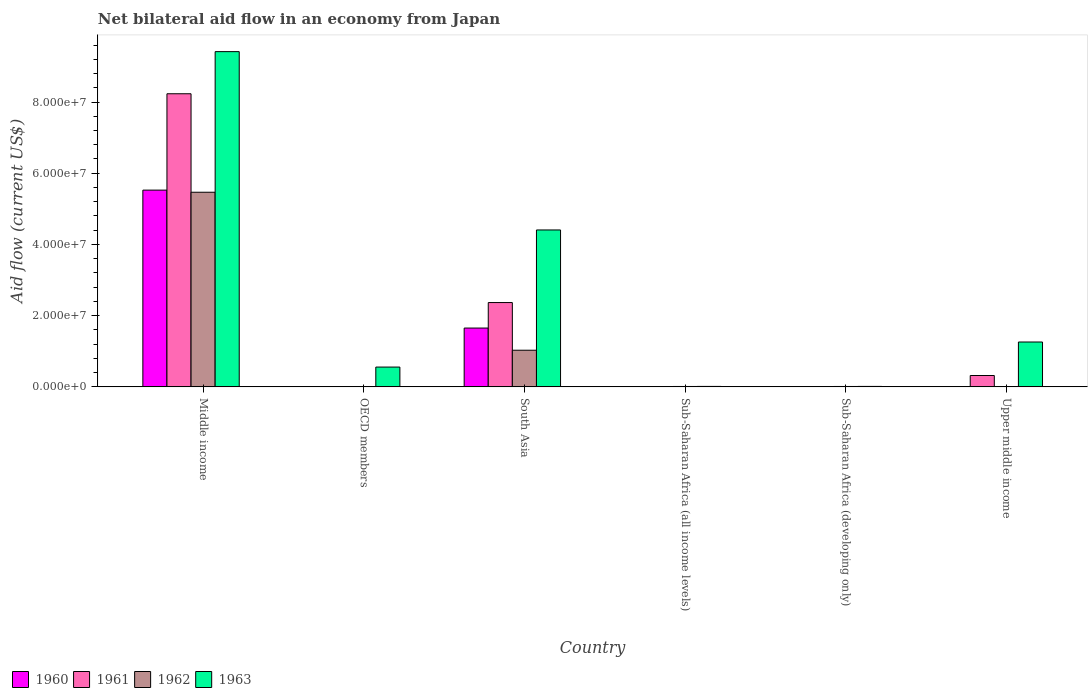How many groups of bars are there?
Keep it short and to the point. 6. Are the number of bars per tick equal to the number of legend labels?
Provide a succinct answer. No. How many bars are there on the 4th tick from the left?
Offer a very short reply. 4. What is the label of the 2nd group of bars from the left?
Keep it short and to the point. OECD members. In how many cases, is the number of bars for a given country not equal to the number of legend labels?
Offer a terse response. 1. Across all countries, what is the maximum net bilateral aid flow in 1962?
Your answer should be very brief. 5.47e+07. What is the total net bilateral aid flow in 1961 in the graph?
Make the answer very short. 1.09e+08. What is the difference between the net bilateral aid flow in 1960 in OECD members and that in Sub-Saharan Africa (developing only)?
Your answer should be compact. 10000. What is the difference between the net bilateral aid flow in 1962 in OECD members and the net bilateral aid flow in 1963 in Upper middle income?
Ensure brevity in your answer.  -1.25e+07. What is the average net bilateral aid flow in 1963 per country?
Your response must be concise. 2.61e+07. What is the difference between the net bilateral aid flow of/in 1963 and net bilateral aid flow of/in 1962 in Middle income?
Provide a short and direct response. 3.95e+07. In how many countries, is the net bilateral aid flow in 1960 greater than 64000000 US$?
Provide a succinct answer. 0. What is the ratio of the net bilateral aid flow in 1961 in OECD members to that in Sub-Saharan Africa (developing only)?
Provide a short and direct response. 1.67. Is the net bilateral aid flow in 1963 in OECD members less than that in Sub-Saharan Africa (developing only)?
Provide a short and direct response. No. Is the difference between the net bilateral aid flow in 1963 in Sub-Saharan Africa (all income levels) and Sub-Saharan Africa (developing only) greater than the difference between the net bilateral aid flow in 1962 in Sub-Saharan Africa (all income levels) and Sub-Saharan Africa (developing only)?
Offer a terse response. No. What is the difference between the highest and the second highest net bilateral aid flow in 1962?
Give a very brief answer. 4.44e+07. What is the difference between the highest and the lowest net bilateral aid flow in 1962?
Provide a short and direct response. 5.47e+07. In how many countries, is the net bilateral aid flow in 1960 greater than the average net bilateral aid flow in 1960 taken over all countries?
Provide a short and direct response. 2. Is the sum of the net bilateral aid flow in 1961 in Sub-Saharan Africa (all income levels) and Sub-Saharan Africa (developing only) greater than the maximum net bilateral aid flow in 1960 across all countries?
Keep it short and to the point. No. Are all the bars in the graph horizontal?
Give a very brief answer. No. What is the difference between two consecutive major ticks on the Y-axis?
Your response must be concise. 2.00e+07. Does the graph contain any zero values?
Provide a succinct answer. Yes. Where does the legend appear in the graph?
Give a very brief answer. Bottom left. What is the title of the graph?
Provide a succinct answer. Net bilateral aid flow in an economy from Japan. Does "2008" appear as one of the legend labels in the graph?
Your response must be concise. No. What is the label or title of the X-axis?
Provide a short and direct response. Country. What is the label or title of the Y-axis?
Make the answer very short. Aid flow (current US$). What is the Aid flow (current US$) in 1960 in Middle income?
Your answer should be very brief. 5.53e+07. What is the Aid flow (current US$) in 1961 in Middle income?
Your answer should be very brief. 8.23e+07. What is the Aid flow (current US$) of 1962 in Middle income?
Your response must be concise. 5.47e+07. What is the Aid flow (current US$) of 1963 in Middle income?
Provide a succinct answer. 9.42e+07. What is the Aid flow (current US$) in 1960 in OECD members?
Your answer should be compact. 3.00e+04. What is the Aid flow (current US$) of 1963 in OECD members?
Keep it short and to the point. 5.56e+06. What is the Aid flow (current US$) in 1960 in South Asia?
Ensure brevity in your answer.  1.65e+07. What is the Aid flow (current US$) of 1961 in South Asia?
Make the answer very short. 2.37e+07. What is the Aid flow (current US$) of 1962 in South Asia?
Offer a terse response. 1.03e+07. What is the Aid flow (current US$) in 1963 in South Asia?
Provide a short and direct response. 4.41e+07. What is the Aid flow (current US$) of 1960 in Sub-Saharan Africa (all income levels)?
Give a very brief answer. 2.00e+04. What is the Aid flow (current US$) in 1960 in Sub-Saharan Africa (developing only)?
Make the answer very short. 2.00e+04. What is the Aid flow (current US$) in 1961 in Sub-Saharan Africa (developing only)?
Provide a short and direct response. 3.00e+04. What is the Aid flow (current US$) of 1963 in Sub-Saharan Africa (developing only)?
Provide a short and direct response. 1.30e+05. What is the Aid flow (current US$) of 1960 in Upper middle income?
Offer a very short reply. 0. What is the Aid flow (current US$) in 1961 in Upper middle income?
Your answer should be very brief. 3.19e+06. What is the Aid flow (current US$) of 1962 in Upper middle income?
Ensure brevity in your answer.  0. What is the Aid flow (current US$) in 1963 in Upper middle income?
Offer a very short reply. 1.26e+07. Across all countries, what is the maximum Aid flow (current US$) in 1960?
Provide a short and direct response. 5.53e+07. Across all countries, what is the maximum Aid flow (current US$) in 1961?
Your response must be concise. 8.23e+07. Across all countries, what is the maximum Aid flow (current US$) of 1962?
Make the answer very short. 5.47e+07. Across all countries, what is the maximum Aid flow (current US$) in 1963?
Provide a succinct answer. 9.42e+07. Across all countries, what is the minimum Aid flow (current US$) in 1960?
Offer a very short reply. 0. Across all countries, what is the minimum Aid flow (current US$) of 1961?
Your answer should be compact. 3.00e+04. Across all countries, what is the minimum Aid flow (current US$) of 1962?
Provide a short and direct response. 0. What is the total Aid flow (current US$) of 1960 in the graph?
Ensure brevity in your answer.  7.18e+07. What is the total Aid flow (current US$) of 1961 in the graph?
Your answer should be compact. 1.09e+08. What is the total Aid flow (current US$) of 1962 in the graph?
Offer a terse response. 6.53e+07. What is the total Aid flow (current US$) in 1963 in the graph?
Your response must be concise. 1.57e+08. What is the difference between the Aid flow (current US$) of 1960 in Middle income and that in OECD members?
Your response must be concise. 5.52e+07. What is the difference between the Aid flow (current US$) of 1961 in Middle income and that in OECD members?
Provide a short and direct response. 8.23e+07. What is the difference between the Aid flow (current US$) in 1962 in Middle income and that in OECD members?
Ensure brevity in your answer.  5.46e+07. What is the difference between the Aid flow (current US$) of 1963 in Middle income and that in OECD members?
Your answer should be very brief. 8.86e+07. What is the difference between the Aid flow (current US$) in 1960 in Middle income and that in South Asia?
Your answer should be very brief. 3.87e+07. What is the difference between the Aid flow (current US$) of 1961 in Middle income and that in South Asia?
Offer a terse response. 5.86e+07. What is the difference between the Aid flow (current US$) in 1962 in Middle income and that in South Asia?
Your answer should be compact. 4.44e+07. What is the difference between the Aid flow (current US$) in 1963 in Middle income and that in South Asia?
Provide a short and direct response. 5.01e+07. What is the difference between the Aid flow (current US$) in 1960 in Middle income and that in Sub-Saharan Africa (all income levels)?
Provide a short and direct response. 5.52e+07. What is the difference between the Aid flow (current US$) in 1961 in Middle income and that in Sub-Saharan Africa (all income levels)?
Your answer should be compact. 8.23e+07. What is the difference between the Aid flow (current US$) in 1962 in Middle income and that in Sub-Saharan Africa (all income levels)?
Offer a terse response. 5.46e+07. What is the difference between the Aid flow (current US$) in 1963 in Middle income and that in Sub-Saharan Africa (all income levels)?
Your answer should be very brief. 9.40e+07. What is the difference between the Aid flow (current US$) in 1960 in Middle income and that in Sub-Saharan Africa (developing only)?
Give a very brief answer. 5.52e+07. What is the difference between the Aid flow (current US$) in 1961 in Middle income and that in Sub-Saharan Africa (developing only)?
Your response must be concise. 8.23e+07. What is the difference between the Aid flow (current US$) of 1962 in Middle income and that in Sub-Saharan Africa (developing only)?
Your answer should be compact. 5.46e+07. What is the difference between the Aid flow (current US$) in 1963 in Middle income and that in Sub-Saharan Africa (developing only)?
Provide a succinct answer. 9.40e+07. What is the difference between the Aid flow (current US$) of 1961 in Middle income and that in Upper middle income?
Ensure brevity in your answer.  7.91e+07. What is the difference between the Aid flow (current US$) in 1963 in Middle income and that in Upper middle income?
Provide a short and direct response. 8.16e+07. What is the difference between the Aid flow (current US$) in 1960 in OECD members and that in South Asia?
Provide a short and direct response. -1.65e+07. What is the difference between the Aid flow (current US$) in 1961 in OECD members and that in South Asia?
Provide a succinct answer. -2.36e+07. What is the difference between the Aid flow (current US$) in 1962 in OECD members and that in South Asia?
Keep it short and to the point. -1.02e+07. What is the difference between the Aid flow (current US$) in 1963 in OECD members and that in South Asia?
Give a very brief answer. -3.85e+07. What is the difference between the Aid flow (current US$) in 1963 in OECD members and that in Sub-Saharan Africa (all income levels)?
Offer a terse response. 5.43e+06. What is the difference between the Aid flow (current US$) of 1960 in OECD members and that in Sub-Saharan Africa (developing only)?
Ensure brevity in your answer.  10000. What is the difference between the Aid flow (current US$) of 1962 in OECD members and that in Sub-Saharan Africa (developing only)?
Your answer should be very brief. -2.00e+04. What is the difference between the Aid flow (current US$) of 1963 in OECD members and that in Sub-Saharan Africa (developing only)?
Offer a very short reply. 5.43e+06. What is the difference between the Aid flow (current US$) of 1961 in OECD members and that in Upper middle income?
Ensure brevity in your answer.  -3.14e+06. What is the difference between the Aid flow (current US$) of 1963 in OECD members and that in Upper middle income?
Give a very brief answer. -7.04e+06. What is the difference between the Aid flow (current US$) in 1960 in South Asia and that in Sub-Saharan Africa (all income levels)?
Your answer should be compact. 1.65e+07. What is the difference between the Aid flow (current US$) of 1961 in South Asia and that in Sub-Saharan Africa (all income levels)?
Keep it short and to the point. 2.36e+07. What is the difference between the Aid flow (current US$) in 1962 in South Asia and that in Sub-Saharan Africa (all income levels)?
Make the answer very short. 1.02e+07. What is the difference between the Aid flow (current US$) of 1963 in South Asia and that in Sub-Saharan Africa (all income levels)?
Ensure brevity in your answer.  4.39e+07. What is the difference between the Aid flow (current US$) of 1960 in South Asia and that in Sub-Saharan Africa (developing only)?
Ensure brevity in your answer.  1.65e+07. What is the difference between the Aid flow (current US$) in 1961 in South Asia and that in Sub-Saharan Africa (developing only)?
Your answer should be very brief. 2.36e+07. What is the difference between the Aid flow (current US$) in 1962 in South Asia and that in Sub-Saharan Africa (developing only)?
Your response must be concise. 1.02e+07. What is the difference between the Aid flow (current US$) in 1963 in South Asia and that in Sub-Saharan Africa (developing only)?
Offer a terse response. 4.39e+07. What is the difference between the Aid flow (current US$) of 1961 in South Asia and that in Upper middle income?
Ensure brevity in your answer.  2.05e+07. What is the difference between the Aid flow (current US$) of 1963 in South Asia and that in Upper middle income?
Provide a succinct answer. 3.15e+07. What is the difference between the Aid flow (current US$) of 1961 in Sub-Saharan Africa (all income levels) and that in Sub-Saharan Africa (developing only)?
Provide a succinct answer. 0. What is the difference between the Aid flow (current US$) in 1961 in Sub-Saharan Africa (all income levels) and that in Upper middle income?
Give a very brief answer. -3.16e+06. What is the difference between the Aid flow (current US$) of 1963 in Sub-Saharan Africa (all income levels) and that in Upper middle income?
Make the answer very short. -1.25e+07. What is the difference between the Aid flow (current US$) of 1961 in Sub-Saharan Africa (developing only) and that in Upper middle income?
Give a very brief answer. -3.16e+06. What is the difference between the Aid flow (current US$) of 1963 in Sub-Saharan Africa (developing only) and that in Upper middle income?
Provide a succinct answer. -1.25e+07. What is the difference between the Aid flow (current US$) in 1960 in Middle income and the Aid flow (current US$) in 1961 in OECD members?
Offer a very short reply. 5.52e+07. What is the difference between the Aid flow (current US$) in 1960 in Middle income and the Aid flow (current US$) in 1962 in OECD members?
Make the answer very short. 5.52e+07. What is the difference between the Aid flow (current US$) of 1960 in Middle income and the Aid flow (current US$) of 1963 in OECD members?
Offer a terse response. 4.97e+07. What is the difference between the Aid flow (current US$) in 1961 in Middle income and the Aid flow (current US$) in 1962 in OECD members?
Your answer should be compact. 8.22e+07. What is the difference between the Aid flow (current US$) in 1961 in Middle income and the Aid flow (current US$) in 1963 in OECD members?
Your answer should be very brief. 7.68e+07. What is the difference between the Aid flow (current US$) in 1962 in Middle income and the Aid flow (current US$) in 1963 in OECD members?
Your answer should be very brief. 4.91e+07. What is the difference between the Aid flow (current US$) of 1960 in Middle income and the Aid flow (current US$) of 1961 in South Asia?
Provide a short and direct response. 3.16e+07. What is the difference between the Aid flow (current US$) in 1960 in Middle income and the Aid flow (current US$) in 1962 in South Asia?
Your answer should be compact. 4.50e+07. What is the difference between the Aid flow (current US$) in 1960 in Middle income and the Aid flow (current US$) in 1963 in South Asia?
Your answer should be very brief. 1.12e+07. What is the difference between the Aid flow (current US$) of 1961 in Middle income and the Aid flow (current US$) of 1962 in South Asia?
Make the answer very short. 7.20e+07. What is the difference between the Aid flow (current US$) in 1961 in Middle income and the Aid flow (current US$) in 1963 in South Asia?
Your answer should be compact. 3.82e+07. What is the difference between the Aid flow (current US$) of 1962 in Middle income and the Aid flow (current US$) of 1963 in South Asia?
Ensure brevity in your answer.  1.06e+07. What is the difference between the Aid flow (current US$) in 1960 in Middle income and the Aid flow (current US$) in 1961 in Sub-Saharan Africa (all income levels)?
Provide a succinct answer. 5.52e+07. What is the difference between the Aid flow (current US$) of 1960 in Middle income and the Aid flow (current US$) of 1962 in Sub-Saharan Africa (all income levels)?
Your answer should be very brief. 5.52e+07. What is the difference between the Aid flow (current US$) in 1960 in Middle income and the Aid flow (current US$) in 1963 in Sub-Saharan Africa (all income levels)?
Make the answer very short. 5.51e+07. What is the difference between the Aid flow (current US$) of 1961 in Middle income and the Aid flow (current US$) of 1962 in Sub-Saharan Africa (all income levels)?
Offer a terse response. 8.22e+07. What is the difference between the Aid flow (current US$) of 1961 in Middle income and the Aid flow (current US$) of 1963 in Sub-Saharan Africa (all income levels)?
Your answer should be compact. 8.22e+07. What is the difference between the Aid flow (current US$) of 1962 in Middle income and the Aid flow (current US$) of 1963 in Sub-Saharan Africa (all income levels)?
Provide a short and direct response. 5.45e+07. What is the difference between the Aid flow (current US$) of 1960 in Middle income and the Aid flow (current US$) of 1961 in Sub-Saharan Africa (developing only)?
Provide a short and direct response. 5.52e+07. What is the difference between the Aid flow (current US$) of 1960 in Middle income and the Aid flow (current US$) of 1962 in Sub-Saharan Africa (developing only)?
Your answer should be compact. 5.52e+07. What is the difference between the Aid flow (current US$) of 1960 in Middle income and the Aid flow (current US$) of 1963 in Sub-Saharan Africa (developing only)?
Ensure brevity in your answer.  5.51e+07. What is the difference between the Aid flow (current US$) of 1961 in Middle income and the Aid flow (current US$) of 1962 in Sub-Saharan Africa (developing only)?
Offer a terse response. 8.22e+07. What is the difference between the Aid flow (current US$) in 1961 in Middle income and the Aid flow (current US$) in 1963 in Sub-Saharan Africa (developing only)?
Make the answer very short. 8.22e+07. What is the difference between the Aid flow (current US$) in 1962 in Middle income and the Aid flow (current US$) in 1963 in Sub-Saharan Africa (developing only)?
Ensure brevity in your answer.  5.45e+07. What is the difference between the Aid flow (current US$) of 1960 in Middle income and the Aid flow (current US$) of 1961 in Upper middle income?
Offer a terse response. 5.21e+07. What is the difference between the Aid flow (current US$) in 1960 in Middle income and the Aid flow (current US$) in 1963 in Upper middle income?
Offer a very short reply. 4.27e+07. What is the difference between the Aid flow (current US$) of 1961 in Middle income and the Aid flow (current US$) of 1963 in Upper middle income?
Your answer should be compact. 6.97e+07. What is the difference between the Aid flow (current US$) of 1962 in Middle income and the Aid flow (current US$) of 1963 in Upper middle income?
Give a very brief answer. 4.21e+07. What is the difference between the Aid flow (current US$) of 1960 in OECD members and the Aid flow (current US$) of 1961 in South Asia?
Offer a terse response. -2.36e+07. What is the difference between the Aid flow (current US$) of 1960 in OECD members and the Aid flow (current US$) of 1962 in South Asia?
Provide a short and direct response. -1.03e+07. What is the difference between the Aid flow (current US$) in 1960 in OECD members and the Aid flow (current US$) in 1963 in South Asia?
Your answer should be very brief. -4.40e+07. What is the difference between the Aid flow (current US$) of 1961 in OECD members and the Aid flow (current US$) of 1962 in South Asia?
Keep it short and to the point. -1.02e+07. What is the difference between the Aid flow (current US$) of 1961 in OECD members and the Aid flow (current US$) of 1963 in South Asia?
Ensure brevity in your answer.  -4.40e+07. What is the difference between the Aid flow (current US$) of 1962 in OECD members and the Aid flow (current US$) of 1963 in South Asia?
Offer a very short reply. -4.40e+07. What is the difference between the Aid flow (current US$) of 1960 in OECD members and the Aid flow (current US$) of 1963 in Sub-Saharan Africa (all income levels)?
Offer a terse response. -1.00e+05. What is the difference between the Aid flow (current US$) in 1961 in OECD members and the Aid flow (current US$) in 1963 in Sub-Saharan Africa (all income levels)?
Offer a very short reply. -8.00e+04. What is the difference between the Aid flow (current US$) in 1960 in OECD members and the Aid flow (current US$) in 1962 in Sub-Saharan Africa (developing only)?
Provide a succinct answer. -8.00e+04. What is the difference between the Aid flow (current US$) in 1960 in OECD members and the Aid flow (current US$) in 1961 in Upper middle income?
Ensure brevity in your answer.  -3.16e+06. What is the difference between the Aid flow (current US$) of 1960 in OECD members and the Aid flow (current US$) of 1963 in Upper middle income?
Your answer should be very brief. -1.26e+07. What is the difference between the Aid flow (current US$) in 1961 in OECD members and the Aid flow (current US$) in 1963 in Upper middle income?
Offer a very short reply. -1.26e+07. What is the difference between the Aid flow (current US$) of 1962 in OECD members and the Aid flow (current US$) of 1963 in Upper middle income?
Keep it short and to the point. -1.25e+07. What is the difference between the Aid flow (current US$) of 1960 in South Asia and the Aid flow (current US$) of 1961 in Sub-Saharan Africa (all income levels)?
Keep it short and to the point. 1.65e+07. What is the difference between the Aid flow (current US$) of 1960 in South Asia and the Aid flow (current US$) of 1962 in Sub-Saharan Africa (all income levels)?
Offer a terse response. 1.64e+07. What is the difference between the Aid flow (current US$) of 1960 in South Asia and the Aid flow (current US$) of 1963 in Sub-Saharan Africa (all income levels)?
Provide a short and direct response. 1.64e+07. What is the difference between the Aid flow (current US$) of 1961 in South Asia and the Aid flow (current US$) of 1962 in Sub-Saharan Africa (all income levels)?
Provide a succinct answer. 2.36e+07. What is the difference between the Aid flow (current US$) of 1961 in South Asia and the Aid flow (current US$) of 1963 in Sub-Saharan Africa (all income levels)?
Your answer should be very brief. 2.36e+07. What is the difference between the Aid flow (current US$) in 1962 in South Asia and the Aid flow (current US$) in 1963 in Sub-Saharan Africa (all income levels)?
Offer a terse response. 1.02e+07. What is the difference between the Aid flow (current US$) of 1960 in South Asia and the Aid flow (current US$) of 1961 in Sub-Saharan Africa (developing only)?
Keep it short and to the point. 1.65e+07. What is the difference between the Aid flow (current US$) of 1960 in South Asia and the Aid flow (current US$) of 1962 in Sub-Saharan Africa (developing only)?
Offer a very short reply. 1.64e+07. What is the difference between the Aid flow (current US$) in 1960 in South Asia and the Aid flow (current US$) in 1963 in Sub-Saharan Africa (developing only)?
Your answer should be compact. 1.64e+07. What is the difference between the Aid flow (current US$) of 1961 in South Asia and the Aid flow (current US$) of 1962 in Sub-Saharan Africa (developing only)?
Your answer should be very brief. 2.36e+07. What is the difference between the Aid flow (current US$) in 1961 in South Asia and the Aid flow (current US$) in 1963 in Sub-Saharan Africa (developing only)?
Provide a short and direct response. 2.36e+07. What is the difference between the Aid flow (current US$) of 1962 in South Asia and the Aid flow (current US$) of 1963 in Sub-Saharan Africa (developing only)?
Make the answer very short. 1.02e+07. What is the difference between the Aid flow (current US$) in 1960 in South Asia and the Aid flow (current US$) in 1961 in Upper middle income?
Give a very brief answer. 1.33e+07. What is the difference between the Aid flow (current US$) of 1960 in South Asia and the Aid flow (current US$) of 1963 in Upper middle income?
Ensure brevity in your answer.  3.92e+06. What is the difference between the Aid flow (current US$) in 1961 in South Asia and the Aid flow (current US$) in 1963 in Upper middle income?
Offer a terse response. 1.11e+07. What is the difference between the Aid flow (current US$) of 1962 in South Asia and the Aid flow (current US$) of 1963 in Upper middle income?
Provide a short and direct response. -2.31e+06. What is the difference between the Aid flow (current US$) of 1962 in Sub-Saharan Africa (all income levels) and the Aid flow (current US$) of 1963 in Sub-Saharan Africa (developing only)?
Your answer should be very brief. -2.00e+04. What is the difference between the Aid flow (current US$) of 1960 in Sub-Saharan Africa (all income levels) and the Aid flow (current US$) of 1961 in Upper middle income?
Provide a succinct answer. -3.17e+06. What is the difference between the Aid flow (current US$) of 1960 in Sub-Saharan Africa (all income levels) and the Aid flow (current US$) of 1963 in Upper middle income?
Offer a very short reply. -1.26e+07. What is the difference between the Aid flow (current US$) of 1961 in Sub-Saharan Africa (all income levels) and the Aid flow (current US$) of 1963 in Upper middle income?
Your response must be concise. -1.26e+07. What is the difference between the Aid flow (current US$) in 1962 in Sub-Saharan Africa (all income levels) and the Aid flow (current US$) in 1963 in Upper middle income?
Provide a succinct answer. -1.25e+07. What is the difference between the Aid flow (current US$) in 1960 in Sub-Saharan Africa (developing only) and the Aid flow (current US$) in 1961 in Upper middle income?
Provide a succinct answer. -3.17e+06. What is the difference between the Aid flow (current US$) of 1960 in Sub-Saharan Africa (developing only) and the Aid flow (current US$) of 1963 in Upper middle income?
Your answer should be very brief. -1.26e+07. What is the difference between the Aid flow (current US$) in 1961 in Sub-Saharan Africa (developing only) and the Aid flow (current US$) in 1963 in Upper middle income?
Offer a terse response. -1.26e+07. What is the difference between the Aid flow (current US$) in 1962 in Sub-Saharan Africa (developing only) and the Aid flow (current US$) in 1963 in Upper middle income?
Your answer should be compact. -1.25e+07. What is the average Aid flow (current US$) of 1960 per country?
Provide a short and direct response. 1.20e+07. What is the average Aid flow (current US$) of 1961 per country?
Ensure brevity in your answer.  1.82e+07. What is the average Aid flow (current US$) of 1962 per country?
Provide a short and direct response. 1.09e+07. What is the average Aid flow (current US$) in 1963 per country?
Ensure brevity in your answer.  2.61e+07. What is the difference between the Aid flow (current US$) in 1960 and Aid flow (current US$) in 1961 in Middle income?
Offer a very short reply. -2.71e+07. What is the difference between the Aid flow (current US$) of 1960 and Aid flow (current US$) of 1963 in Middle income?
Your response must be concise. -3.89e+07. What is the difference between the Aid flow (current US$) of 1961 and Aid flow (current US$) of 1962 in Middle income?
Your answer should be compact. 2.77e+07. What is the difference between the Aid flow (current US$) in 1961 and Aid flow (current US$) in 1963 in Middle income?
Offer a terse response. -1.18e+07. What is the difference between the Aid flow (current US$) of 1962 and Aid flow (current US$) of 1963 in Middle income?
Your response must be concise. -3.95e+07. What is the difference between the Aid flow (current US$) of 1960 and Aid flow (current US$) of 1962 in OECD members?
Keep it short and to the point. -6.00e+04. What is the difference between the Aid flow (current US$) in 1960 and Aid flow (current US$) in 1963 in OECD members?
Make the answer very short. -5.53e+06. What is the difference between the Aid flow (current US$) in 1961 and Aid flow (current US$) in 1962 in OECD members?
Your answer should be very brief. -4.00e+04. What is the difference between the Aid flow (current US$) in 1961 and Aid flow (current US$) in 1963 in OECD members?
Offer a terse response. -5.51e+06. What is the difference between the Aid flow (current US$) in 1962 and Aid flow (current US$) in 1963 in OECD members?
Keep it short and to the point. -5.47e+06. What is the difference between the Aid flow (current US$) in 1960 and Aid flow (current US$) in 1961 in South Asia?
Your response must be concise. -7.16e+06. What is the difference between the Aid flow (current US$) of 1960 and Aid flow (current US$) of 1962 in South Asia?
Offer a very short reply. 6.23e+06. What is the difference between the Aid flow (current US$) in 1960 and Aid flow (current US$) in 1963 in South Asia?
Offer a very short reply. -2.76e+07. What is the difference between the Aid flow (current US$) of 1961 and Aid flow (current US$) of 1962 in South Asia?
Your answer should be compact. 1.34e+07. What is the difference between the Aid flow (current US$) of 1961 and Aid flow (current US$) of 1963 in South Asia?
Provide a short and direct response. -2.04e+07. What is the difference between the Aid flow (current US$) in 1962 and Aid flow (current US$) in 1963 in South Asia?
Your answer should be very brief. -3.38e+07. What is the difference between the Aid flow (current US$) in 1960 and Aid flow (current US$) in 1961 in Sub-Saharan Africa (all income levels)?
Ensure brevity in your answer.  -10000. What is the difference between the Aid flow (current US$) in 1961 and Aid flow (current US$) in 1963 in Sub-Saharan Africa (all income levels)?
Ensure brevity in your answer.  -1.00e+05. What is the difference between the Aid flow (current US$) in 1962 and Aid flow (current US$) in 1963 in Sub-Saharan Africa (all income levels)?
Offer a very short reply. -2.00e+04. What is the difference between the Aid flow (current US$) of 1960 and Aid flow (current US$) of 1961 in Sub-Saharan Africa (developing only)?
Your answer should be compact. -10000. What is the difference between the Aid flow (current US$) in 1961 and Aid flow (current US$) in 1963 in Sub-Saharan Africa (developing only)?
Your answer should be very brief. -1.00e+05. What is the difference between the Aid flow (current US$) of 1961 and Aid flow (current US$) of 1963 in Upper middle income?
Give a very brief answer. -9.41e+06. What is the ratio of the Aid flow (current US$) in 1960 in Middle income to that in OECD members?
Provide a succinct answer. 1842. What is the ratio of the Aid flow (current US$) in 1961 in Middle income to that in OECD members?
Make the answer very short. 1646.4. What is the ratio of the Aid flow (current US$) in 1962 in Middle income to that in OECD members?
Your answer should be compact. 607.33. What is the ratio of the Aid flow (current US$) of 1963 in Middle income to that in OECD members?
Your response must be concise. 16.93. What is the ratio of the Aid flow (current US$) of 1960 in Middle income to that in South Asia?
Ensure brevity in your answer.  3.35. What is the ratio of the Aid flow (current US$) in 1961 in Middle income to that in South Asia?
Ensure brevity in your answer.  3.48. What is the ratio of the Aid flow (current US$) of 1962 in Middle income to that in South Asia?
Give a very brief answer. 5.31. What is the ratio of the Aid flow (current US$) of 1963 in Middle income to that in South Asia?
Your response must be concise. 2.14. What is the ratio of the Aid flow (current US$) of 1960 in Middle income to that in Sub-Saharan Africa (all income levels)?
Your response must be concise. 2763. What is the ratio of the Aid flow (current US$) in 1961 in Middle income to that in Sub-Saharan Africa (all income levels)?
Ensure brevity in your answer.  2744. What is the ratio of the Aid flow (current US$) in 1962 in Middle income to that in Sub-Saharan Africa (all income levels)?
Provide a succinct answer. 496.91. What is the ratio of the Aid flow (current US$) of 1963 in Middle income to that in Sub-Saharan Africa (all income levels)?
Make the answer very short. 724.23. What is the ratio of the Aid flow (current US$) of 1960 in Middle income to that in Sub-Saharan Africa (developing only)?
Your response must be concise. 2763. What is the ratio of the Aid flow (current US$) in 1961 in Middle income to that in Sub-Saharan Africa (developing only)?
Ensure brevity in your answer.  2744. What is the ratio of the Aid flow (current US$) in 1962 in Middle income to that in Sub-Saharan Africa (developing only)?
Your answer should be compact. 496.91. What is the ratio of the Aid flow (current US$) in 1963 in Middle income to that in Sub-Saharan Africa (developing only)?
Offer a very short reply. 724.23. What is the ratio of the Aid flow (current US$) in 1961 in Middle income to that in Upper middle income?
Your answer should be compact. 25.81. What is the ratio of the Aid flow (current US$) of 1963 in Middle income to that in Upper middle income?
Keep it short and to the point. 7.47. What is the ratio of the Aid flow (current US$) of 1960 in OECD members to that in South Asia?
Make the answer very short. 0. What is the ratio of the Aid flow (current US$) of 1961 in OECD members to that in South Asia?
Keep it short and to the point. 0. What is the ratio of the Aid flow (current US$) in 1962 in OECD members to that in South Asia?
Provide a succinct answer. 0.01. What is the ratio of the Aid flow (current US$) in 1963 in OECD members to that in South Asia?
Your answer should be compact. 0.13. What is the ratio of the Aid flow (current US$) of 1960 in OECD members to that in Sub-Saharan Africa (all income levels)?
Your response must be concise. 1.5. What is the ratio of the Aid flow (current US$) in 1961 in OECD members to that in Sub-Saharan Africa (all income levels)?
Keep it short and to the point. 1.67. What is the ratio of the Aid flow (current US$) of 1962 in OECD members to that in Sub-Saharan Africa (all income levels)?
Provide a succinct answer. 0.82. What is the ratio of the Aid flow (current US$) of 1963 in OECD members to that in Sub-Saharan Africa (all income levels)?
Keep it short and to the point. 42.77. What is the ratio of the Aid flow (current US$) in 1961 in OECD members to that in Sub-Saharan Africa (developing only)?
Ensure brevity in your answer.  1.67. What is the ratio of the Aid flow (current US$) in 1962 in OECD members to that in Sub-Saharan Africa (developing only)?
Your response must be concise. 0.82. What is the ratio of the Aid flow (current US$) in 1963 in OECD members to that in Sub-Saharan Africa (developing only)?
Provide a succinct answer. 42.77. What is the ratio of the Aid flow (current US$) in 1961 in OECD members to that in Upper middle income?
Offer a terse response. 0.02. What is the ratio of the Aid flow (current US$) of 1963 in OECD members to that in Upper middle income?
Offer a terse response. 0.44. What is the ratio of the Aid flow (current US$) of 1960 in South Asia to that in Sub-Saharan Africa (all income levels)?
Provide a short and direct response. 826. What is the ratio of the Aid flow (current US$) in 1961 in South Asia to that in Sub-Saharan Africa (all income levels)?
Give a very brief answer. 789.33. What is the ratio of the Aid flow (current US$) of 1962 in South Asia to that in Sub-Saharan Africa (all income levels)?
Offer a very short reply. 93.55. What is the ratio of the Aid flow (current US$) in 1963 in South Asia to that in Sub-Saharan Africa (all income levels)?
Give a very brief answer. 339. What is the ratio of the Aid flow (current US$) of 1960 in South Asia to that in Sub-Saharan Africa (developing only)?
Your answer should be compact. 826. What is the ratio of the Aid flow (current US$) of 1961 in South Asia to that in Sub-Saharan Africa (developing only)?
Make the answer very short. 789.33. What is the ratio of the Aid flow (current US$) of 1962 in South Asia to that in Sub-Saharan Africa (developing only)?
Offer a very short reply. 93.55. What is the ratio of the Aid flow (current US$) in 1963 in South Asia to that in Sub-Saharan Africa (developing only)?
Offer a very short reply. 339. What is the ratio of the Aid flow (current US$) of 1961 in South Asia to that in Upper middle income?
Ensure brevity in your answer.  7.42. What is the ratio of the Aid flow (current US$) of 1963 in South Asia to that in Upper middle income?
Offer a terse response. 3.5. What is the ratio of the Aid flow (current US$) in 1960 in Sub-Saharan Africa (all income levels) to that in Sub-Saharan Africa (developing only)?
Offer a terse response. 1. What is the ratio of the Aid flow (current US$) in 1962 in Sub-Saharan Africa (all income levels) to that in Sub-Saharan Africa (developing only)?
Your response must be concise. 1. What is the ratio of the Aid flow (current US$) in 1961 in Sub-Saharan Africa (all income levels) to that in Upper middle income?
Offer a very short reply. 0.01. What is the ratio of the Aid flow (current US$) in 1963 in Sub-Saharan Africa (all income levels) to that in Upper middle income?
Offer a very short reply. 0.01. What is the ratio of the Aid flow (current US$) in 1961 in Sub-Saharan Africa (developing only) to that in Upper middle income?
Your answer should be compact. 0.01. What is the ratio of the Aid flow (current US$) of 1963 in Sub-Saharan Africa (developing only) to that in Upper middle income?
Your answer should be very brief. 0.01. What is the difference between the highest and the second highest Aid flow (current US$) of 1960?
Make the answer very short. 3.87e+07. What is the difference between the highest and the second highest Aid flow (current US$) in 1961?
Make the answer very short. 5.86e+07. What is the difference between the highest and the second highest Aid flow (current US$) in 1962?
Offer a very short reply. 4.44e+07. What is the difference between the highest and the second highest Aid flow (current US$) in 1963?
Ensure brevity in your answer.  5.01e+07. What is the difference between the highest and the lowest Aid flow (current US$) in 1960?
Keep it short and to the point. 5.53e+07. What is the difference between the highest and the lowest Aid flow (current US$) in 1961?
Make the answer very short. 8.23e+07. What is the difference between the highest and the lowest Aid flow (current US$) of 1962?
Keep it short and to the point. 5.47e+07. What is the difference between the highest and the lowest Aid flow (current US$) of 1963?
Keep it short and to the point. 9.40e+07. 